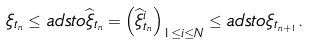<formula> <loc_0><loc_0><loc_500><loc_500>\xi _ { t _ { n } } \leq a d s t o \widehat { \xi } _ { t _ { n } } = \left ( \widehat { \xi } _ { t _ { n } } ^ { i } \right ) _ { 1 \leq i \leq N } \leq a d s t o \xi _ { t _ { n + 1 } } .</formula> 